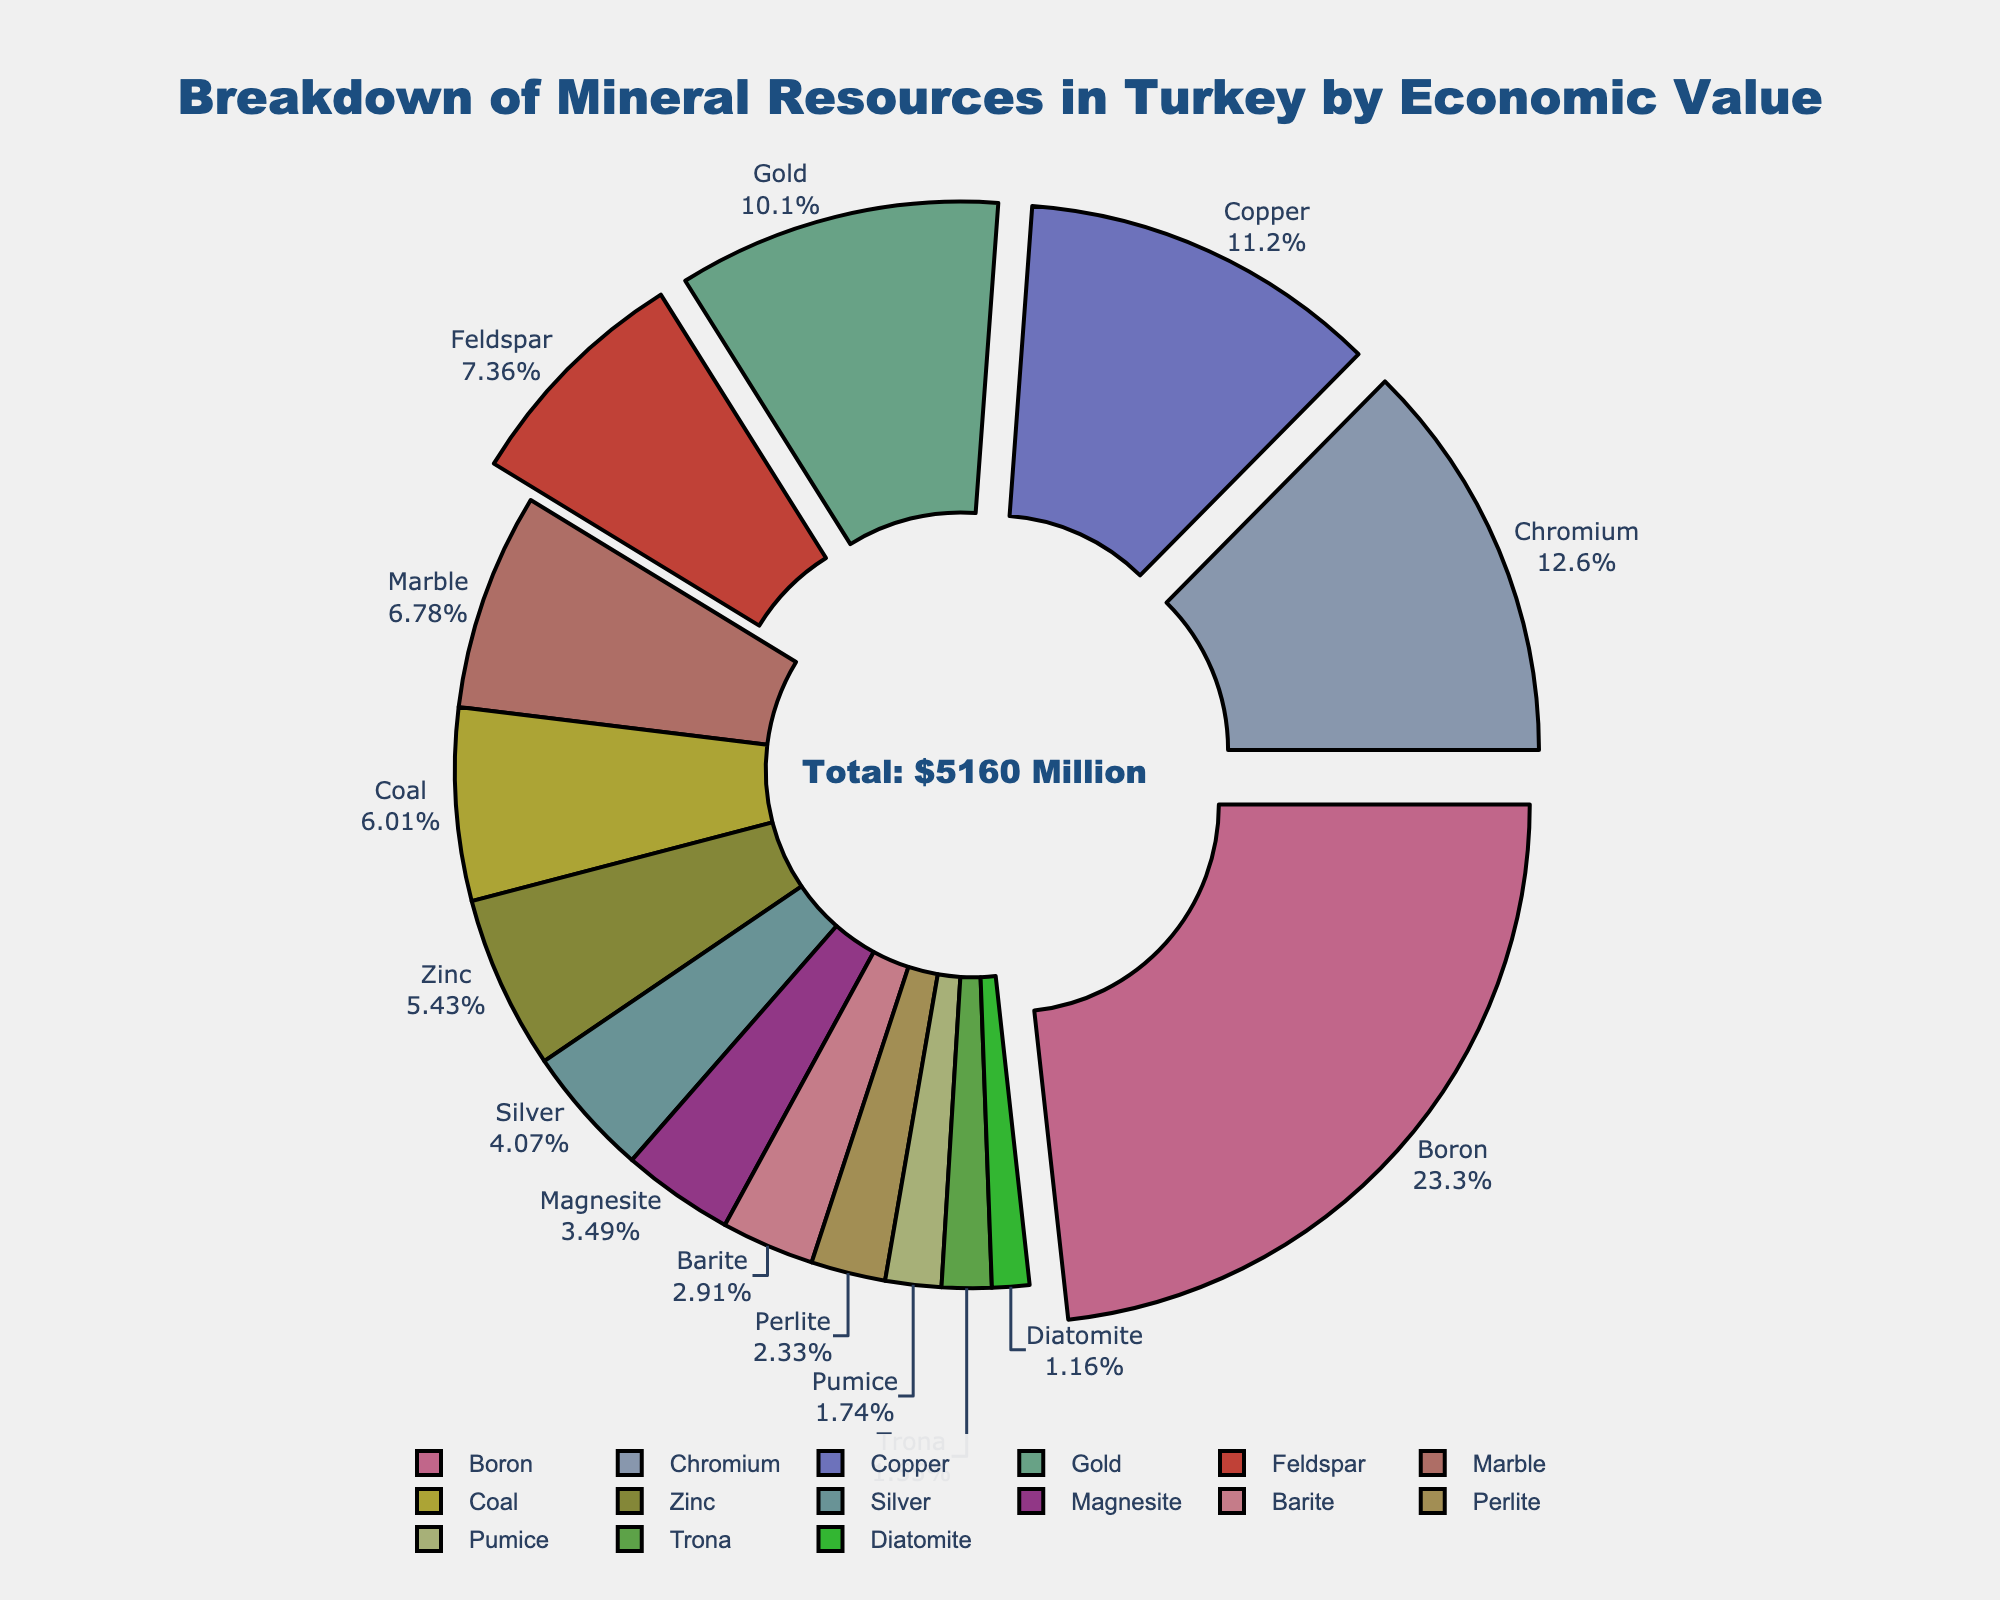Which mineral has the highest economic value? The mineral with the highest economic value will be represented by the largest segment in the pie chart.
Answer: Boron What percentage of the total economic value is contributed by Gold? Identify the segment labeled "Gold," which shows both the label and the percentage contribution to the total economic value.
Answer: 7.54% How does the economic value of Copper compare to that of Zinc? Check the pie chart for the segments labeled "Copper" and "Zinc" to compare their sizes or their value labels. Copper's segment is larger than Zinc's.
Answer: Copper is higher Which minerals are highlighted or pulled out in the pie chart? Look for segments that are visually pulled out or separated slightly from the rest, typically highlighting top contributors.
Answer: Boron, Chromium, Copper, Gold, Feldspar What is the combined economic value of Coal and Silver? Find the individual values for Coal and Silver from the labels on the chart, and then sum them up (310 + 210).
Answer: 520 Million USD How many minerals contribute less than 5% each to the total economic value? Look at the percentage labels on each segment; count the number of minerals where the percentage is less than 5%.
Answer: 10 minerals What color represents the economic value of Marble? Identify the segment labeled "Marble" and observe its color.
Answer: Light brown (or description based on actual color seen) Is the economic value of Trona greater than or less than that of Pumice? Compare the segments labeled "Trona" and "Pumice" in terms of size or value labels; Trona's segment is smaller.
Answer: Less than What is the total economic value of the top three minerals? Sum the economic values of Boron, Chromium, and Copper, the top three highest values (1200 + 650 + 580).
Answer: 2430 Million USD Which mineral contributes approximately 3.35% to the total economic value? Look for the segment labeled with approximately 3.35% of the total, which corresponds to the label.
Answer: Coal 